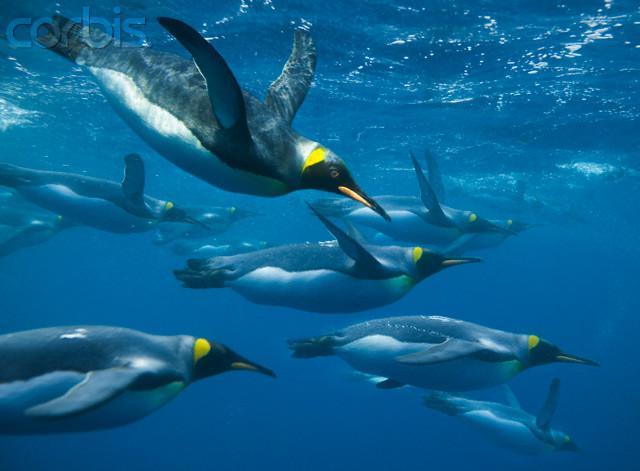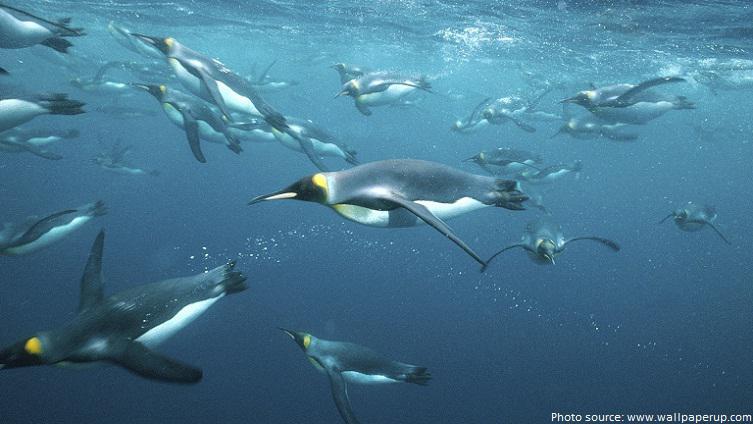The first image is the image on the left, the second image is the image on the right. Considering the images on both sides, is "There is no more than two penguins swimming underwater in the right image." valid? Answer yes or no. No. The first image is the image on the left, the second image is the image on the right. For the images displayed, is the sentence "All of the images in each set shows a multitude of penguins as they swim underwater." factually correct? Answer yes or no. Yes. 